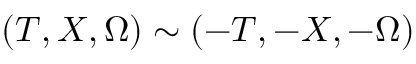Convert formula to latex. <formula><loc_0><loc_0><loc_500><loc_500>( T , X , \Omega ) \sim ( - T , - X , - \Omega )</formula> 